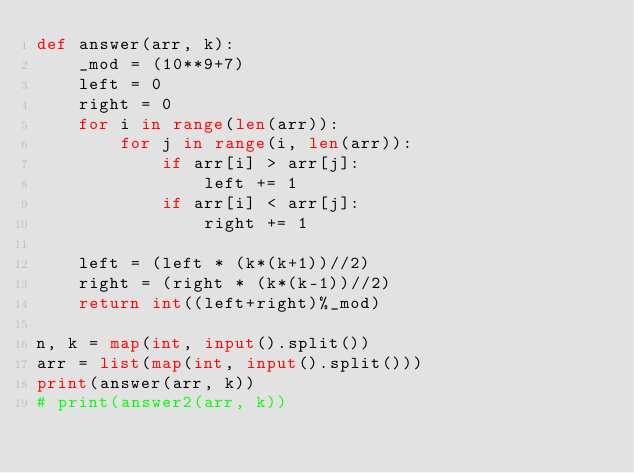Convert code to text. <code><loc_0><loc_0><loc_500><loc_500><_Python_>def answer(arr, k):
    _mod = (10**9+7)
    left = 0
    right = 0
    for i in range(len(arr)):
        for j in range(i, len(arr)):
            if arr[i] > arr[j]:
                left += 1
            if arr[i] < arr[j]:
                right += 1
    
    left = (left * (k*(k+1))//2)
    right = (right * (k*(k-1))//2)
    return int((left+right)%_mod)
    
n, k = map(int, input().split())
arr = list(map(int, input().split()))
print(answer(arr, k))
# print(answer2(arr, k))</code> 